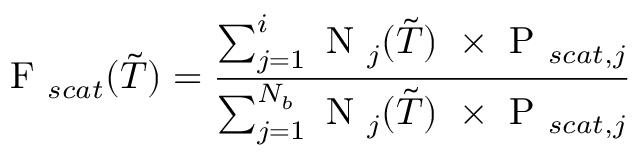<formula> <loc_0><loc_0><loc_500><loc_500>F _ { s c a t } ( \tilde { T } ) = \frac { \sum _ { j = 1 } ^ { i } N _ { j } ( \tilde { T } ) \ \times P _ { s c a t , j } } { \sum _ { j = 1 } ^ { N _ { b } } N _ { j } ( \tilde { T } ) \ \times P _ { s c a t , j } }</formula> 